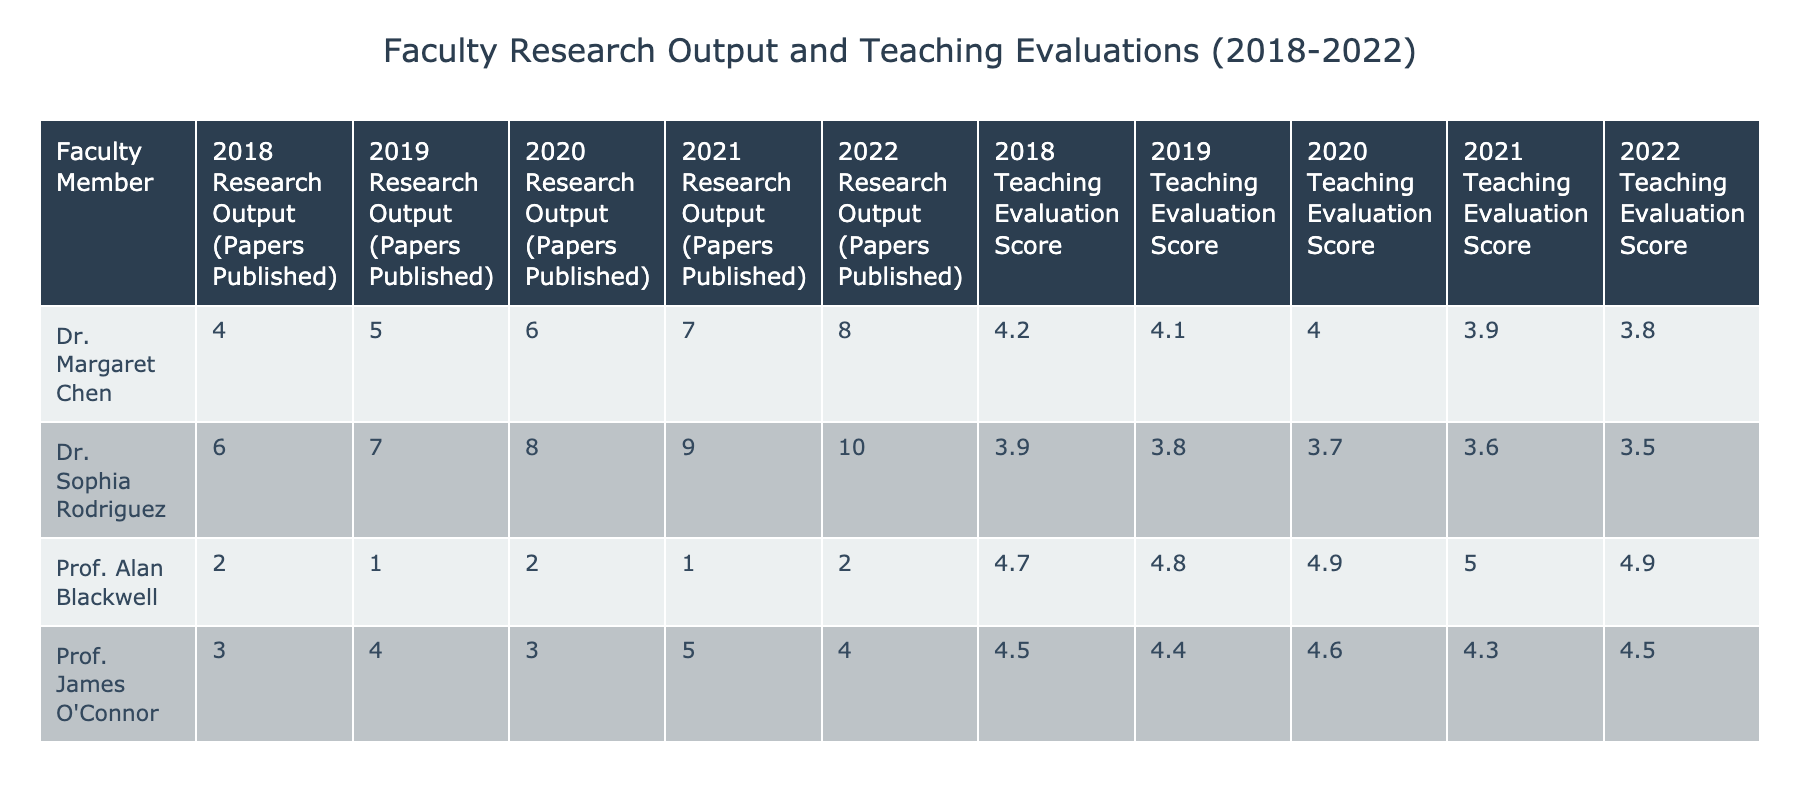What was Dr. Margaret Chen's research output in 2020? In 2020, Dr. Margaret Chen published 6 papers as indicated in her row under that year in the table.
Answer: 6 What is the highest teaching evaluation score among the faculty members in 2019? In 2019, Prof. Alan Blackwell had the highest teaching evaluation score of 4.8, as seen in his 2019 row.
Answer: 4.8 How many total papers did Dr. Sophia Rodriguez publish from 2018 to 2022? The total output can be calculated by adding her papers published over the years: 6 (2018) + 7 (2019) + 8 (2020) + 9 (2021) + 10 (2022) = 40.
Answer: 40 Did Prof. Alan Blackwell's teaching evaluation score increase every year? No, his scores were 4.7 (2018), 4.8 (2019), 4.9 (2020), 5.0 (2021), then dropped to 4.9 (2022), indicating fluctuations.
Answer: No What was the average research output of Prof. James O'Connor from 2018 to 2022? Calculating the average: (3 + 4 + 3 + 5 + 4) / 5 = 3.8, as he published 3 papers in 2018, 4 in 2019, 3 in 2020, 5 in 2021, and 4 in 2022.
Answer: 3.8 Which faculty member had the most consistent teaching evaluations over the years? Dr. Sophia Rodriguez's teaching evaluations decreased steadily from 3.9 in 2018 to 3.5 in 2022, showing a consistent trend of decline.
Answer: No How much did Dr. Margaret Chen's research output increase from 2018 to 2022? Dr. Margaret Chen's output increased from 4 papers published in 2018 to 8 in 2022, resulting in an increase of 4 papers.
Answer: 4 papers What was the difference in teaching evaluation scores between Dr. Sophia Rodriguez in 2018 and 2022? The difference is calculated as 3.9 (2018) - 3.5 (2022) = 0.4, indicating a decline of 0.4 points.
Answer: 0.4 In which year did Prof. Alan Blackwell achieve the highest teaching evaluation score? Prof. Alan Blackwell had his highest score of 5.0 in 2021 according to the table.
Answer: 2021 What was the total research output of all faculty members in 2019? The total is calculated as follows: 5 (Margaret) + 1 (Alan) + 7 (Sophia) + 4 (James) = 17 papers published that year.
Answer: 17 Which faculty member had the lowest teaching evaluation score in the table? Dr. Sophia Rodriguez had the lowest score in 2022 at 3.5, based on her evaluation scores throughout the years.
Answer: 3.5 